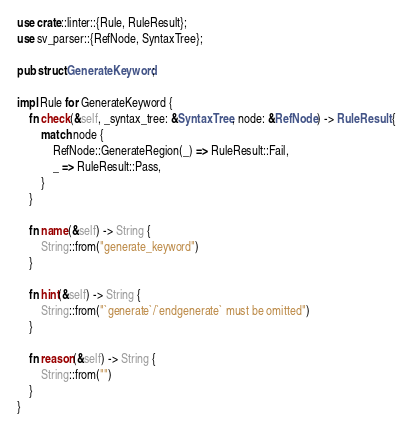Convert code to text. <code><loc_0><loc_0><loc_500><loc_500><_Rust_>use crate::linter::{Rule, RuleResult};
use sv_parser::{RefNode, SyntaxTree};

pub struct GenerateKeyword;

impl Rule for GenerateKeyword {
    fn check(&self, _syntax_tree: &SyntaxTree, node: &RefNode) -> RuleResult {
        match node {
            RefNode::GenerateRegion(_) => RuleResult::Fail,
            _ => RuleResult::Pass,
        }
    }

    fn name(&self) -> String {
        String::from("generate_keyword")
    }

    fn hint(&self) -> String {
        String::from("`generate`/`endgenerate` must be omitted")
    }

    fn reason(&self) -> String {
        String::from("")
    }
}
</code> 